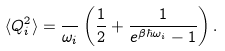<formula> <loc_0><loc_0><loc_500><loc_500>\langle Q _ { i } ^ { 2 } \rangle = \frac { } { \omega _ { i } } \left ( \frac { 1 } { 2 } + \frac { 1 } { e ^ { \beta \hbar { \omega } _ { i } } - 1 } \right ) .</formula> 